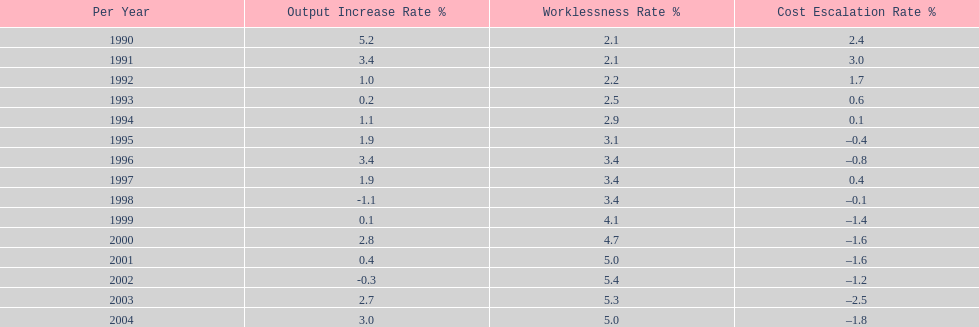What year had the highest unemployment rate? 2002. 